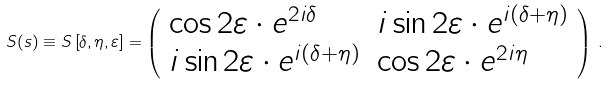<formula> <loc_0><loc_0><loc_500><loc_500>S ( s ) \equiv S \left [ \delta , \eta , \varepsilon \right ] = \left ( \begin{array} { l l } \cos { 2 \varepsilon } \cdot e ^ { 2 i \delta } & i \sin { 2 \varepsilon } \cdot e ^ { i ( \delta + \eta ) } \\ i \sin { 2 \varepsilon } \cdot e ^ { i ( \delta + \eta ) } & \cos { 2 \varepsilon } \cdot e ^ { 2 i \eta } \end{array} \right ) \, .</formula> 